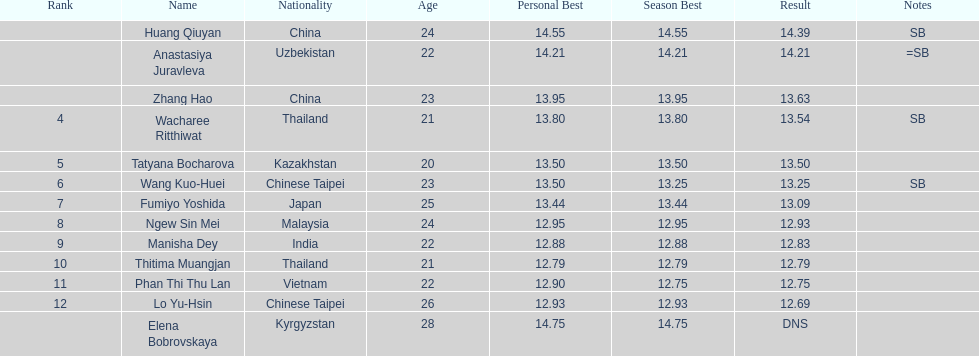Parse the table in full. {'header': ['Rank', 'Name', 'Nationality', 'Age', 'Personal Best', 'Season Best', 'Result', 'Notes'], 'rows': [['', 'Huang Qiuyan', 'China', '24', '14.55', '14.55', '14.39', 'SB'], ['', 'Anastasiya Juravleva', 'Uzbekistan', '22', '14.21', '14.21', '14.21', '=SB'], ['', 'Zhang Hao', 'China', '23', '13.95', '13.95', '13.63', ''], ['4', 'Wacharee Ritthiwat', 'Thailand', '21', '13.80', '13.80', '13.54', 'SB'], ['5', 'Tatyana Bocharova', 'Kazakhstan', '20', '13.50', '13.50', '13.50', ''], ['6', 'Wang Kuo-Huei', 'Chinese Taipei', '23', '13.50', '13.25', '13.25', 'SB'], ['7', 'Fumiyo Yoshida', 'Japan', '25', '13.44', '13.44', '13.09', ''], ['8', 'Ngew Sin Mei', 'Malaysia', '24', '12.95', '12.95', '12.93', ''], ['9', 'Manisha Dey', 'India', '22', '12.88', '12.88', '12.83', ''], ['10', 'Thitima Muangjan', 'Thailand', '21', '12.79', '12.79', '12.79', ''], ['11', 'Phan Thi Thu Lan', 'Vietnam', '22', '12.90', '12.75', '12.75', ''], ['12', 'Lo Yu-Hsin', 'Chinese Taipei', '26', '12.93', '12.93', '12.69', ''], ['', 'Elena Bobrovskaya', 'Kyrgyzstan', '28', '14.75', '14.75', 'DNS', '']]} What is the difference between huang qiuyan's result and fumiyo yoshida's result? 1.3. 